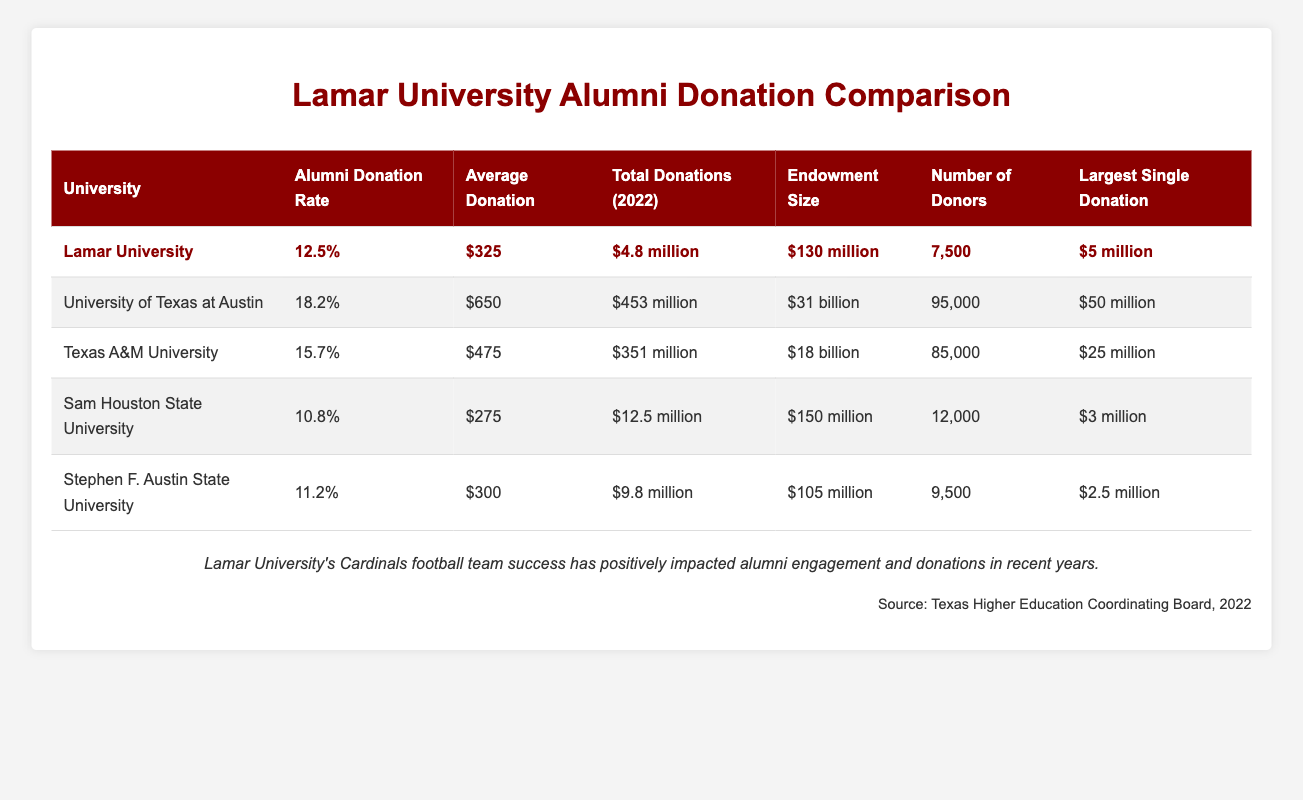What is the alumni donation rate for Lamar University? The alumni donation rate for Lamar University is stated directly in the table under the "Alumni Donation Rate" column, which shows 12.5%.
Answer: 12.5% How many total donations did Lamar University receive in 2022? The total donations for Lamar University in 2022 can be found in the "Total Donations (2022)" column, showing $4.8 million.
Answer: $4.8 million Which university has the highest alumni donation rate? By comparing the "Alumni Donation Rate" percentages of all universities in the table, the University of Texas at Austin has the highest rate at 18.2%.
Answer: University of Texas at Austin What is the average donation amount for Texas A&M University? The average donation amount for Texas A&M University is listed in the table under "Average Donation," which is $475.
Answer: $475 Is Lamar University's average donation amount higher than Sam Houston State University's? Lamar University's average donation amount is $325, while Sam Houston State University's average donation amount is $275. Since $325 is greater than $275, the answer is yes.
Answer: Yes What is the difference in total donations between the University of Texas at Austin and Lamar University? The total donations for the University of Texas at Austin are $453 million, and for Lamar University, it is $4.8 million. To find the difference, we subtract: $453 million - $4.8 million = $448.2 million.
Answer: $448.2 million How many donors did Stephen F. Austin State University have compared to Lamar University? Stephen F. Austin State University had 9,500 donors, while Lamar University had 7,500 donors. Therefore, Stephen F. Austin State University had more donors than Lamar University.
Answer: Stephen F. Austin State University had more donors Which university had the largest single donation, and what was the amount? The table indicates that the University of Texas at Austin received the largest single donation of $50 million.
Answer: University of Texas at Austin; $50 million If we average the alumni donation rates of all five universities, what is the result? The alumni donation rates are 12.5%, 18.2%, 15.7%, 10.8%, and 11.2%. Adding these gives us 68.4%. Then we divide by 5 to find the average: 68.4% / 5 = 13.68%.
Answer: 13.68% 